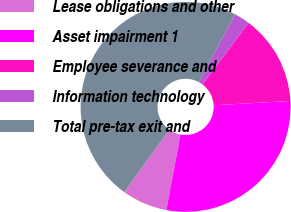Convert chart to OTSL. <chart><loc_0><loc_0><loc_500><loc_500><pie_chart><fcel>Lease obligations and other<fcel>Asset impairment 1<fcel>Employee severance and<fcel>Information technology<fcel>Total pre-tax exit and<nl><fcel>6.98%<fcel>28.82%<fcel>13.86%<fcel>2.44%<fcel>47.89%<nl></chart> 